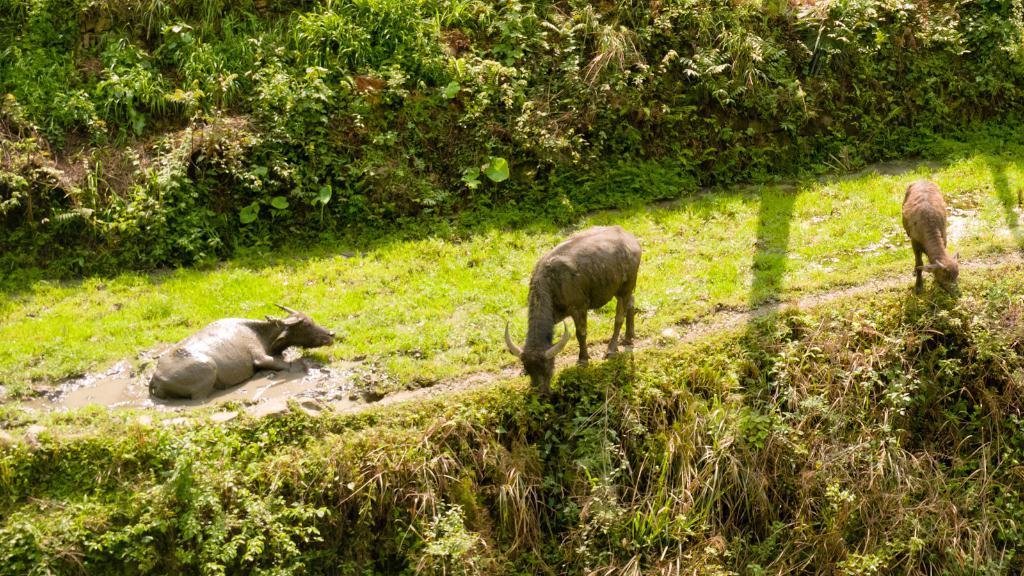Describe this image in one or two sentences. On the left side of the image, we can see a bull in the mud. In the middle and right side of the image, we can see animals are on the ground. At the bottom of the image, there are so many plants. In the background, we can see grass and plants. 